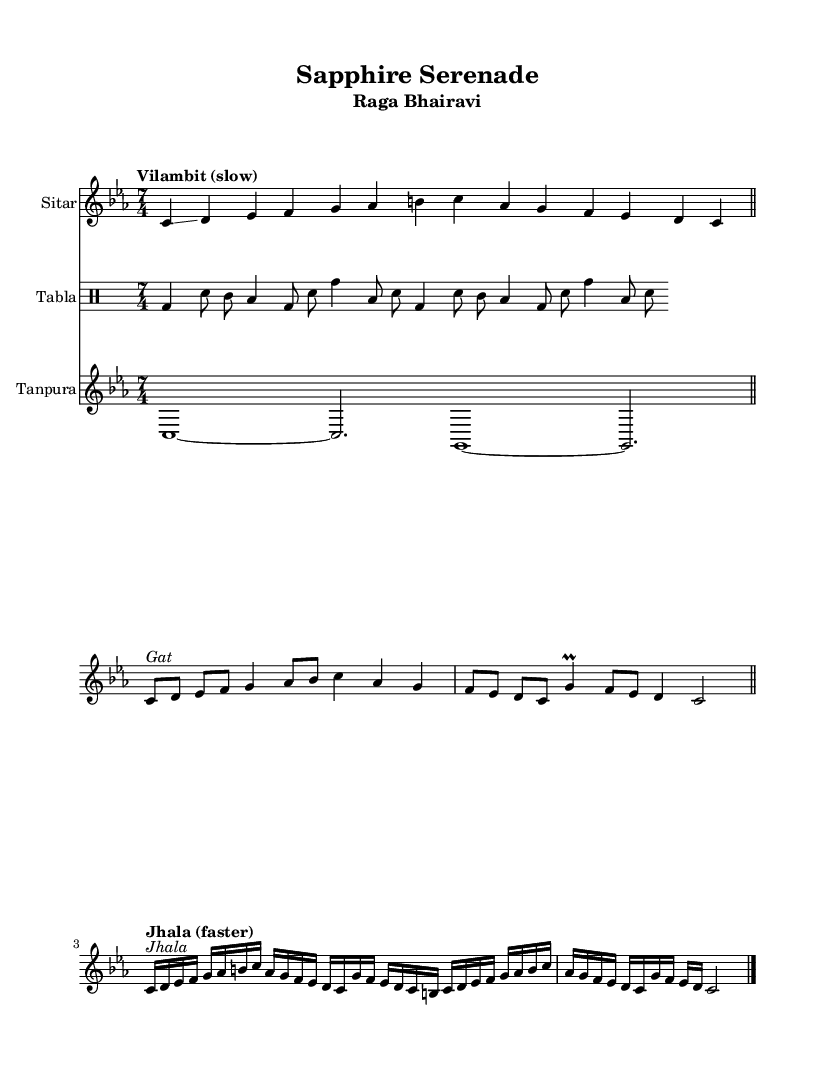What is the key signature of this music? The key signature is C minor, which is indicated by the presence of three flats.
Answer: C minor What is the time signature of this piece? The time signature is indicated at the beginning of the score as 7/4, meaning there are seven beats in each measure with a quarter note receiving one beat.
Answer: 7/4 What is the tempo marking for the 'Alap' section? The tempo marking for the 'Alap' section is "Vilambit (slow)", indicating a slower, more contemplative pace for the music.
Answer: Vilambit (slow) How many measures are in the 'Gat' section? The 'Gat' section is marked to repeat twice, indicating there are two measures that are played two times. Each section has a different number of beats, but total measures would be considered as two due to the repeat.
Answer: 2 What type of musical composition is being represented here? The composition reflects traditional Indian classical music, specifically structured with distinct sections like Alap, Gat, and Jhala, which are typical of ragas in this musical style.
Answer: Indian classical How many instruments are featured in the score? The score features three instruments: the sitar, tabla, and tanpura, as indicated by separate staff notation for each.
Answer: 3 What is the defining characteristic of 'Jhala' in this score? The 'Jhala' section is recognized by a change in tempo to "faster," noted at the beginning of the section, which contrasts with the previous sections, capturing a lively and vibrant essence.
Answer: Faster 